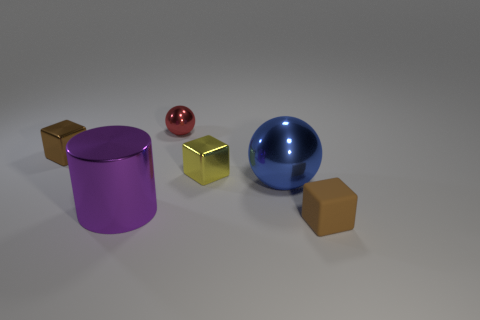There is a tiny brown thing that is behind the small brown matte thing; is it the same shape as the yellow metallic thing?
Your response must be concise. Yes. What is the color of the big object that is behind the purple metallic cylinder?
Provide a succinct answer. Blue. The purple object that is made of the same material as the big blue thing is what shape?
Your response must be concise. Cylinder. Is there anything else that has the same color as the rubber object?
Provide a short and direct response. Yes. Are there more yellow objects in front of the large purple metallic cylinder than tiny metallic spheres that are to the right of the blue object?
Keep it short and to the point. No. How many yellow blocks have the same size as the purple metal thing?
Offer a very short reply. 0. Is the number of small matte things that are left of the large blue object less than the number of balls that are on the right side of the red metallic thing?
Keep it short and to the point. Yes. Are there any tiny yellow objects of the same shape as the red metal object?
Offer a very short reply. No. Is the small yellow metal thing the same shape as the blue metallic object?
Give a very brief answer. No. What number of tiny objects are purple things or brown shiny cubes?
Make the answer very short. 1. 